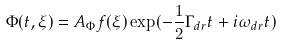Convert formula to latex. <formula><loc_0><loc_0><loc_500><loc_500>\Phi ( t , \xi ) = A _ { \Phi } f ( \xi ) \exp ( - \frac { 1 } { 2 } \Gamma _ { d r } t + i \omega _ { d r } t )</formula> 